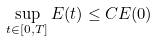Convert formula to latex. <formula><loc_0><loc_0><loc_500><loc_500>\sup _ { t \in [ 0 , T ] } E ( t ) \leq C E ( 0 )</formula> 